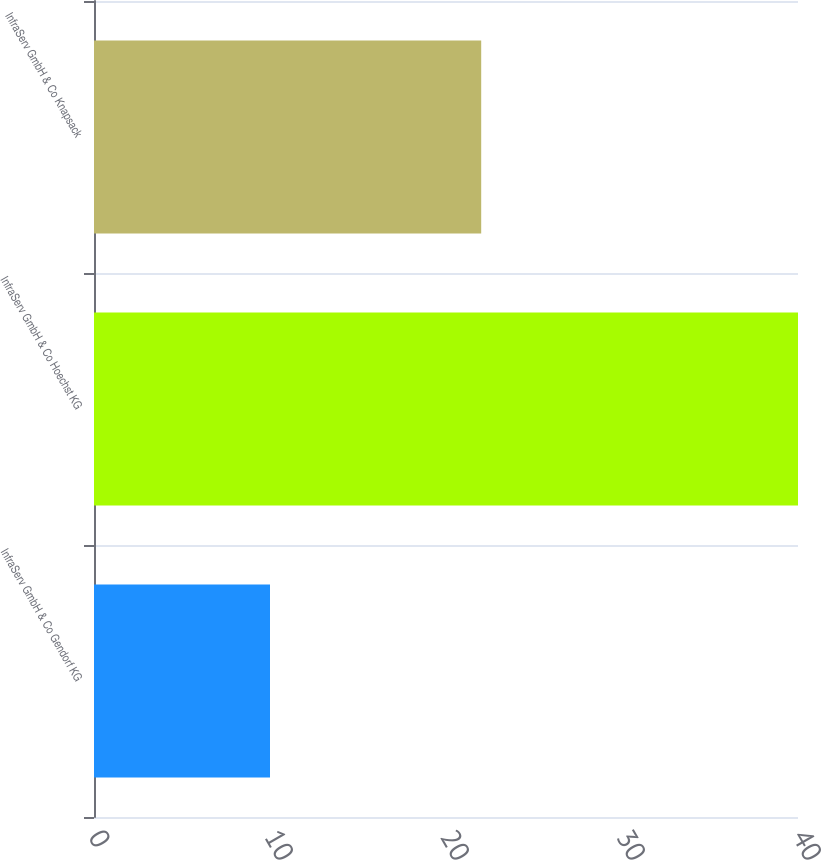<chart> <loc_0><loc_0><loc_500><loc_500><bar_chart><fcel>InfraServ GmbH & Co Gendorf KG<fcel>InfraServ GmbH & Co Hoechst KG<fcel>InfraServ GmbH & Co Knapsack<nl><fcel>10<fcel>40<fcel>22<nl></chart> 